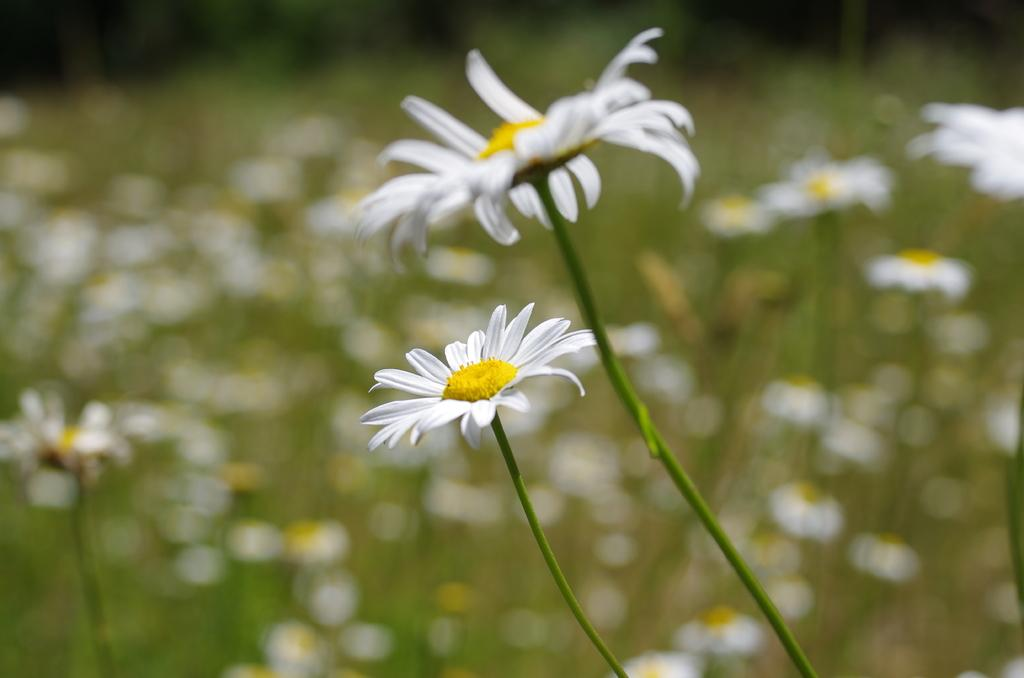What type of plant elements are visible in the image? There are stems with flowers in the image. What can be seen in the background of the image? The background of the image includes flowers. How would you describe the clarity of the image? The image is blurry. What type of sand can be seen in the image? There is no sand present in the image; it features stems with flowers and a flowery background. Can you describe the bird that is perched on the giraffe in the image? There are no birds or giraffes present in the image. 